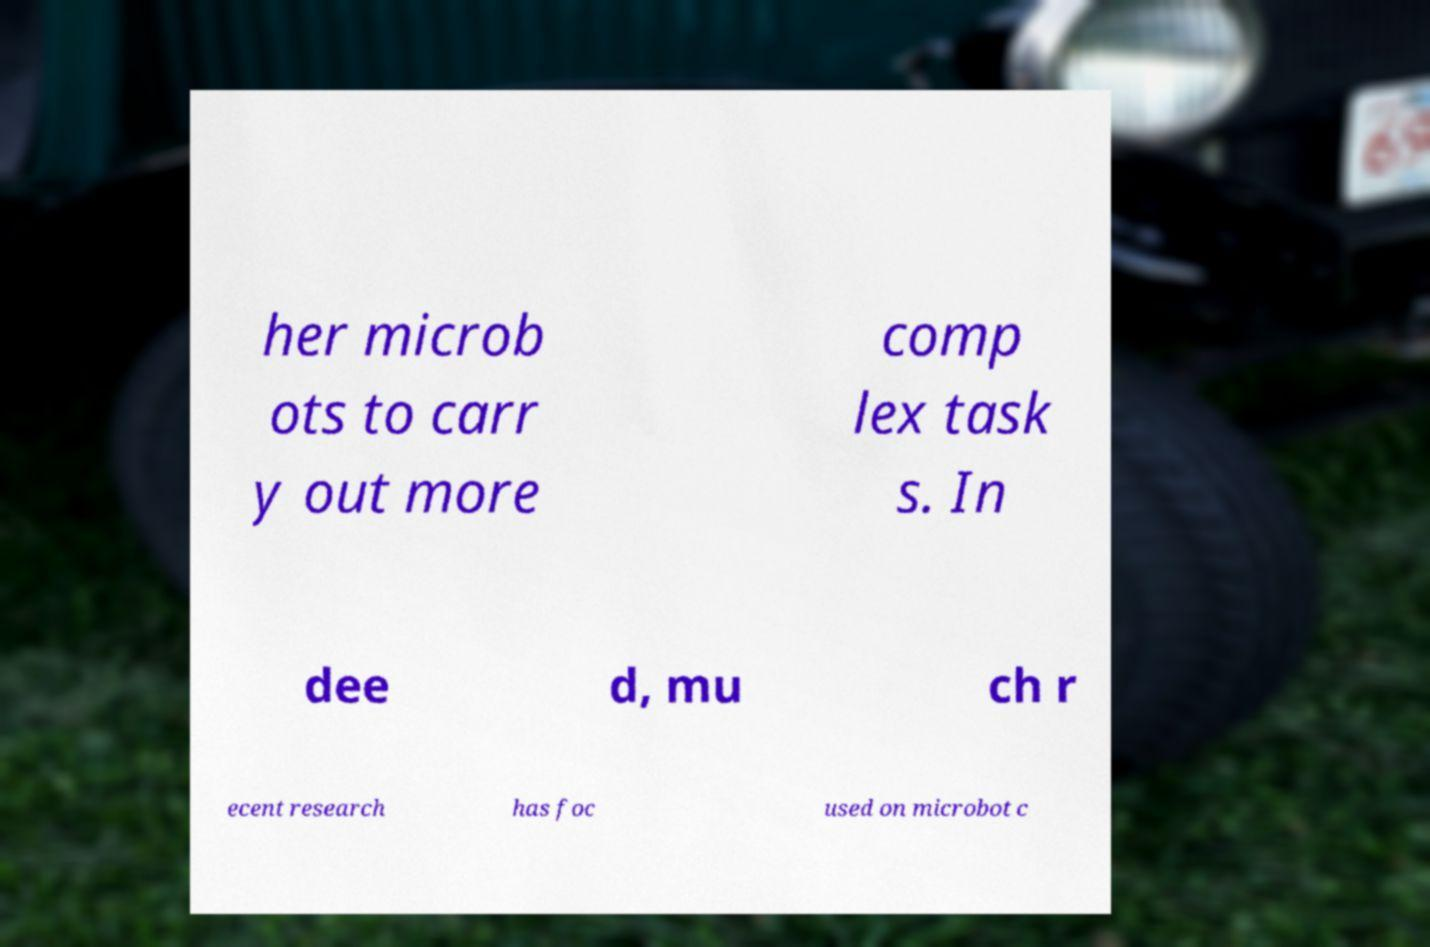Can you read and provide the text displayed in the image?This photo seems to have some interesting text. Can you extract and type it out for me? her microb ots to carr y out more comp lex task s. In dee d, mu ch r ecent research has foc used on microbot c 